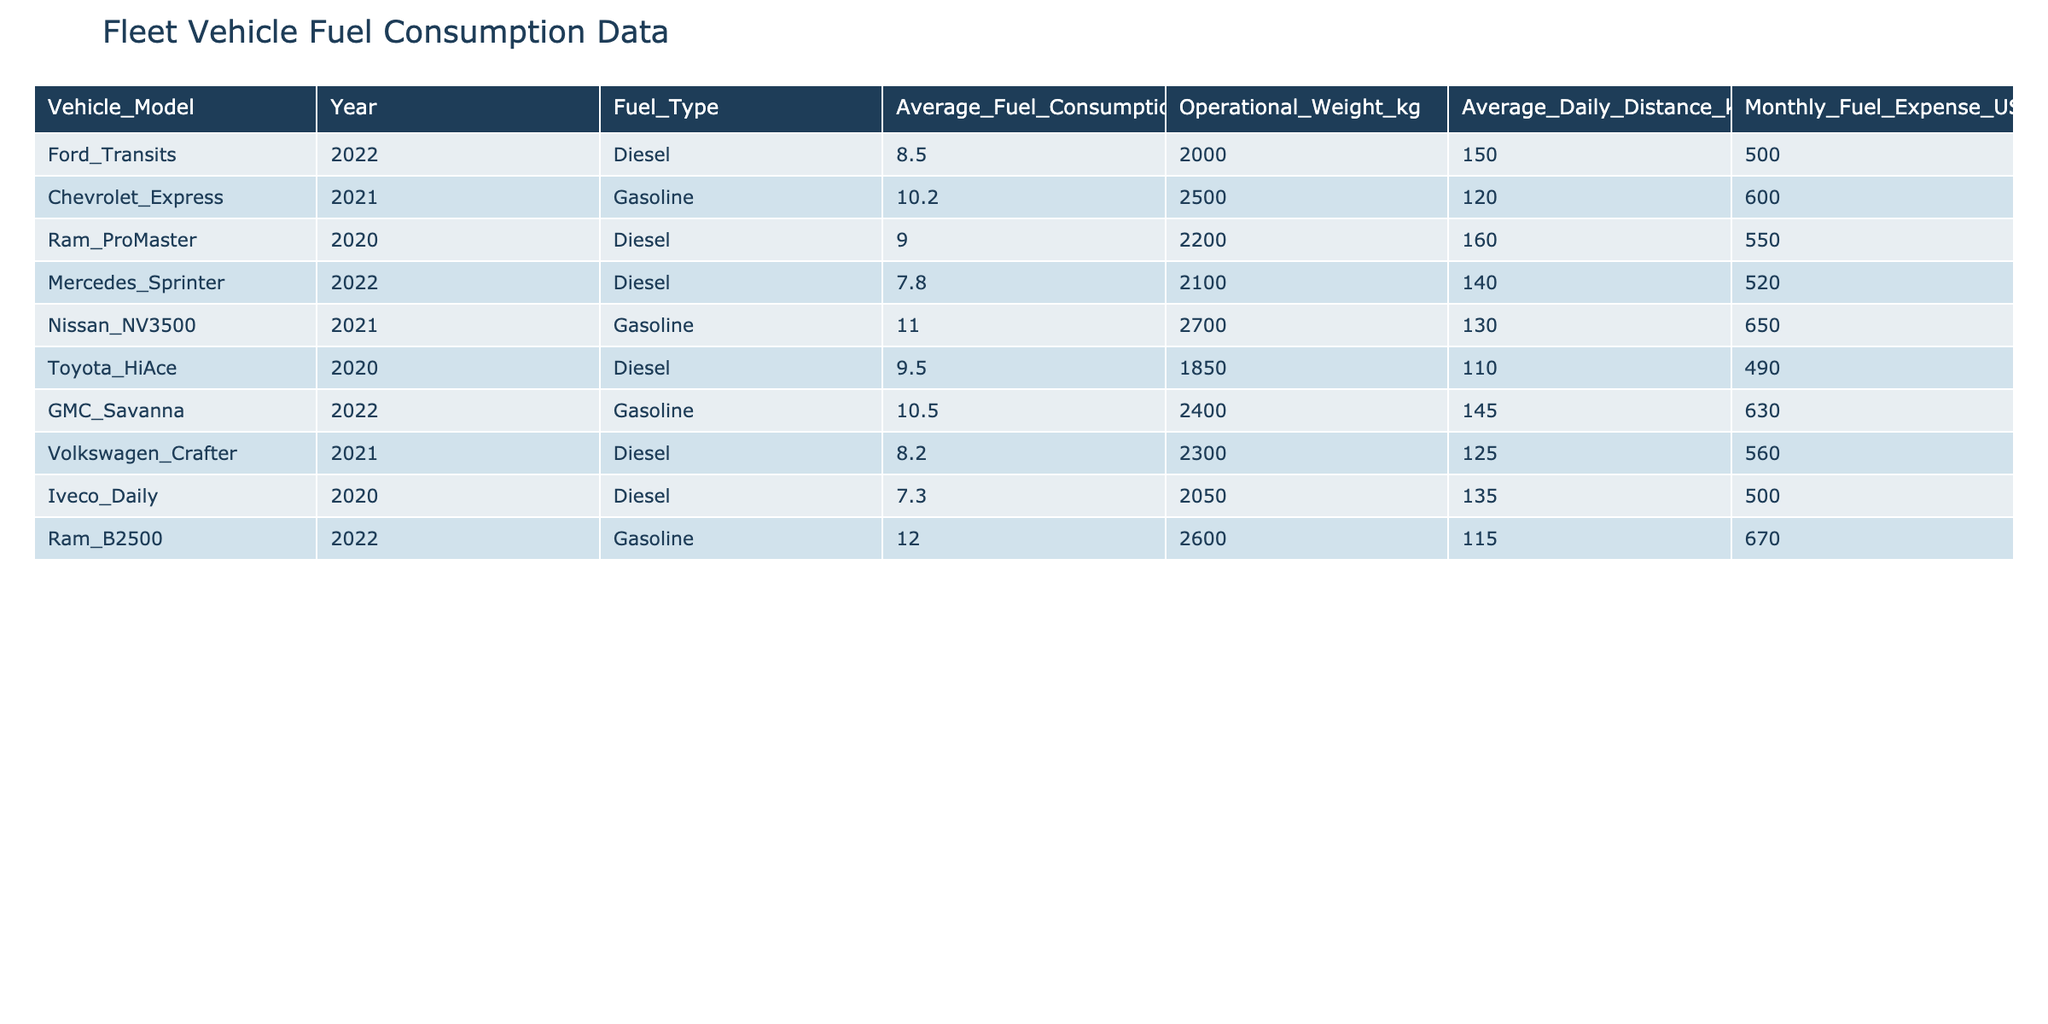What is the average fuel consumption of the Ford Transits? The average fuel consumption of the Ford Transits is listed in the table under the column "Average_Fuel_Consumption_L_per_100km." It shows 8.5 L/100km.
Answer: 8.5 L/100km Which vehicle has the highest operational weight? Looking at the "Operational_Weight_kg" column, the vehicle with the highest value is the Nissan NV3500, which weighs 2700 kg.
Answer: Nissan NV3500 What is the average monthly fuel expense for all diesel vehicles in the fleet? To find the average monthly fuel expense for diesel vehicles, we need to look at the "Monthly_Fuel_Expense_USD" for diesel vehicles, which are Ford Transits, Ram ProMaster, Mercedes Sprinter, Toyota HiAce, Volkswagen Crafter, and Iveco Daily. Their expenses are 500, 550, 520, 490, 560, and 500 respectively. Summing these expenses gives 3120, and dividing by 6 (the number of diesel vehicles) gives an average expense of 520.
Answer: 520 USD Is the Ram ProMaster's fuel consumption higher than that of the Mercedes Sprinter? The Ram ProMaster's fuel consumption is 9.0 L/100km, while the Mercedes Sprinter's is 7.8 L/100km. Since 9.0 is greater than 7.8, the statement is true.
Answer: Yes What is the difference in average fuel consumption between the highest and lowest consuming gasoline vehicles? The highest gasoline fuel consumption is from the Ram B2500 at 12.0 L/100km and the lowest is from the Chevrolet Express at 10.2 L/100km. The difference is 12.0 - 10.2 = 1.8 L/100km.
Answer: 1.8 L/100km How many vehicles have fuel consumption rates higher than 10 L/100km? Checking the "Average_Fuel_Consumption_L_per_100km" column, the vehicles with rates higher than 10 L/100km are the Chevrolet Express (10.2), Nissan NV3500 (11.0), and Ram B2500 (12.0). Thus, there are three vehicles in total.
Answer: 3 vehicles What percentage of the fleet uses gasoline as a fuel type? There are 4 gasoline vehicles (Chevrolet Express, GMC Savanna, Ram B2500, and Nissan NV3500) out of a total of 10 vehicles in the table. To calculate the percentage, we use (4/10) * 100 = 40%.
Answer: 40% Which vehicle has the best average fuel consumption among the listed models? The vehicle with the best average fuel consumption can be found by comparing the values in the "Average_Fuel_Consumption_L_per_100km" column. The lowest value is 7.3 L/100km, attributed to the Iveco Daily.
Answer: Iveco Daily 